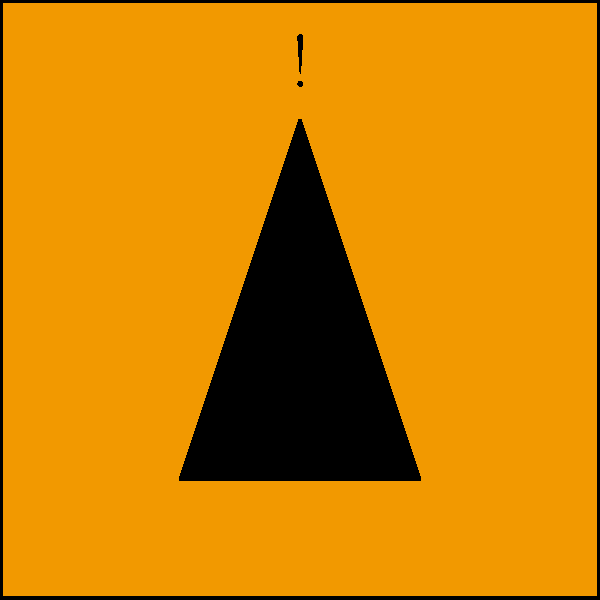As a lab director, you come across a container with the pictogram shown above. What hazard does this standardized symbol represent, and what precautions should be taken when handling substances with this label? To answer this question, let's break down the components of the pictogram and their meanings:

1. Orange background: This color is commonly used for warning signs, indicating potential danger.

2. Black flame symbol: The flame represents fire or ignition.

3. Exclamation mark: This emphasizes the importance of the warning.

These elements combined indicate that the pictogram represents flammable substances. As a lab director, you should be aware of the following precautions:

1. Store these substances away from heat sources, sparks, and open flames.
2. Ensure proper ventilation in storage and handling areas.
3. Use appropriate personal protective equipment (PPE) when handling.
4. Have fire extinguishers readily available in the vicinity.
5. Train staff on proper handling and emergency procedures.
6. Implement a chemical inventory system to track these substances.
7. Ensure compatibility with other chemicals in storage.

The correct interpretation of this symbol is crucial for maintaining safety in the laboratory environment.
Answer: Flammable substances; store away from heat/sparks, ensure ventilation, use PPE, have fire extinguishers ready. 